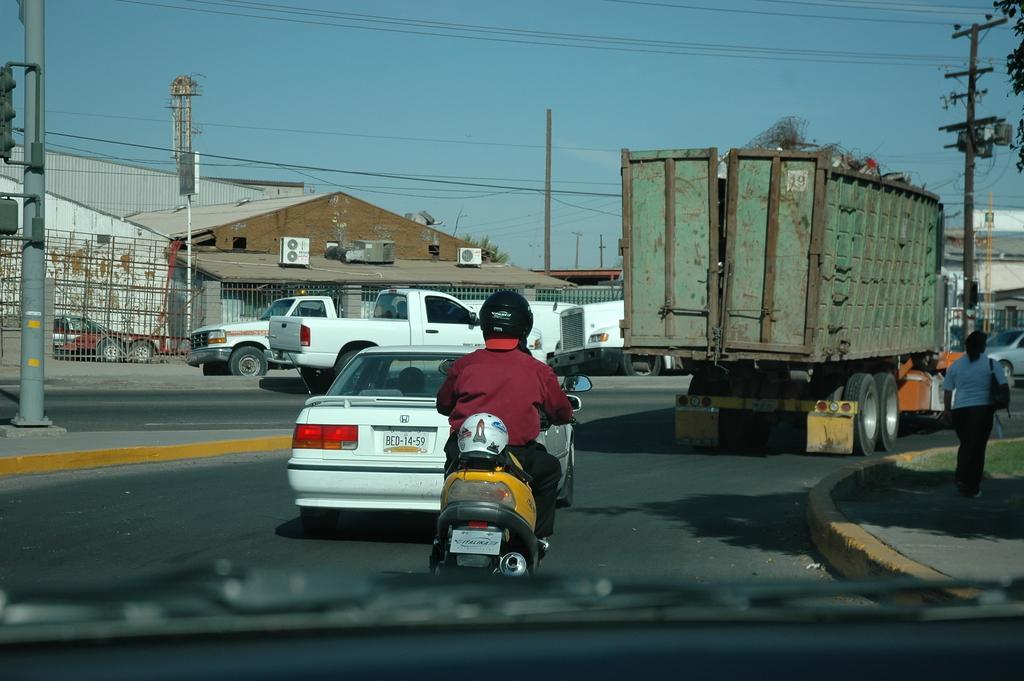Describe this image in one or two sentences. In this picture I can see a man riding a vehicle, there are vehicles on the road, there are houses, there is a person standing, there are air conditioners, there are iron grilles, poles, cables, and in the background there is sky. 